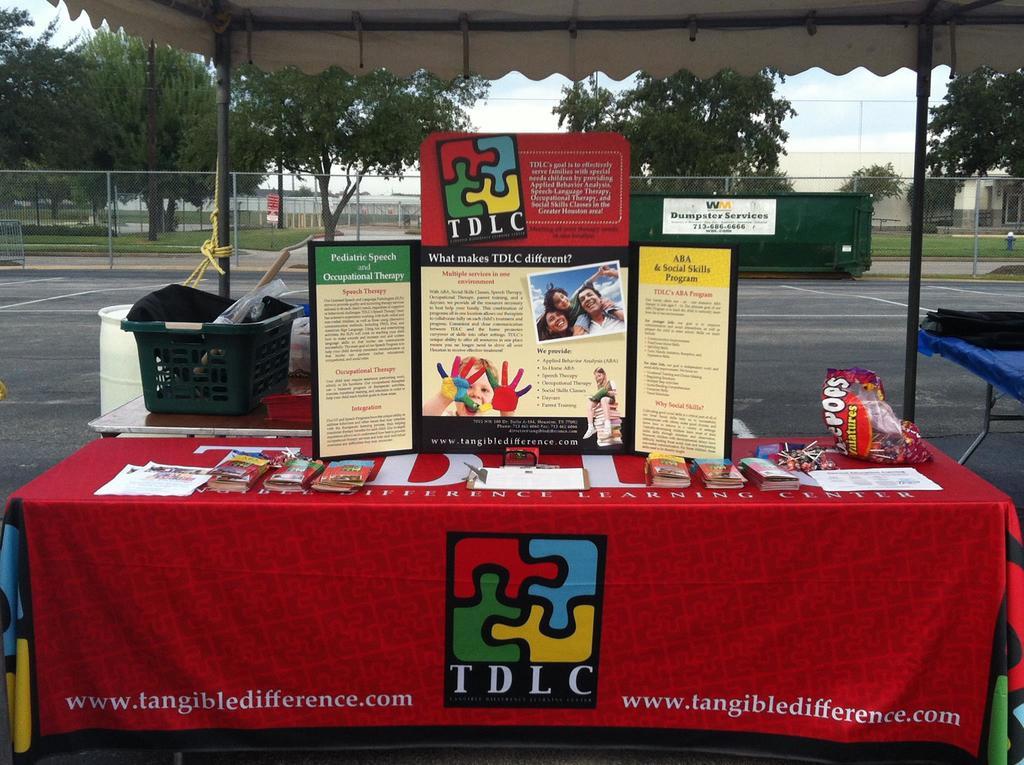What website is printed at the bottom of the banner?
Provide a short and direct response. Www.tangibledifference.com. 